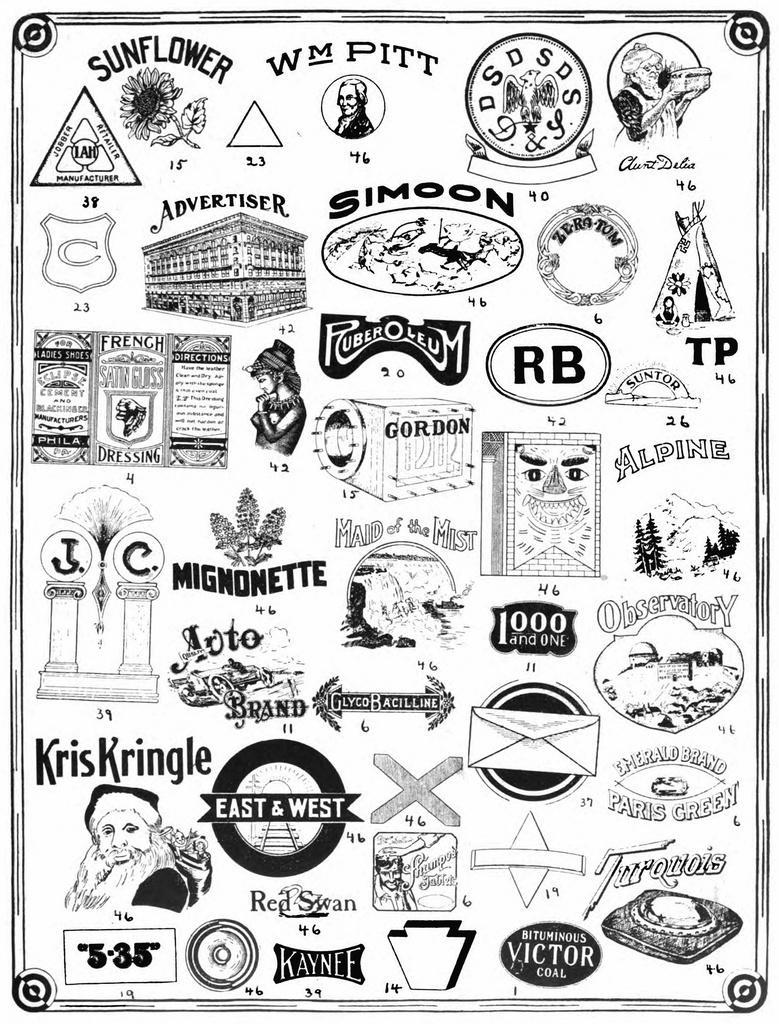Please provide a concise description of this image. In this picture we can see few arts, symbols and some text. 